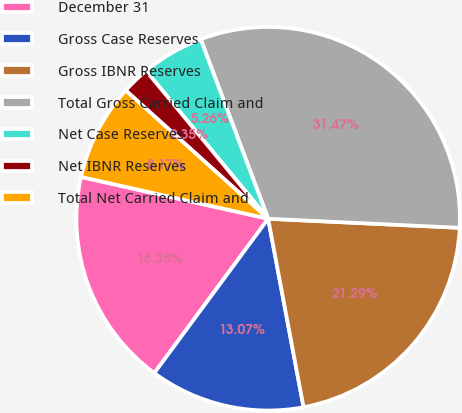Convert chart. <chart><loc_0><loc_0><loc_500><loc_500><pie_chart><fcel>December 31<fcel>Gross Case Reserves<fcel>Gross IBNR Reserves<fcel>Total Gross Carried Claim and<fcel>Net Case Reserves<fcel>Net IBNR Reserves<fcel>Total Net Carried Claim and<nl><fcel>18.38%<fcel>13.07%<fcel>21.29%<fcel>31.47%<fcel>5.26%<fcel>2.35%<fcel>8.17%<nl></chart> 